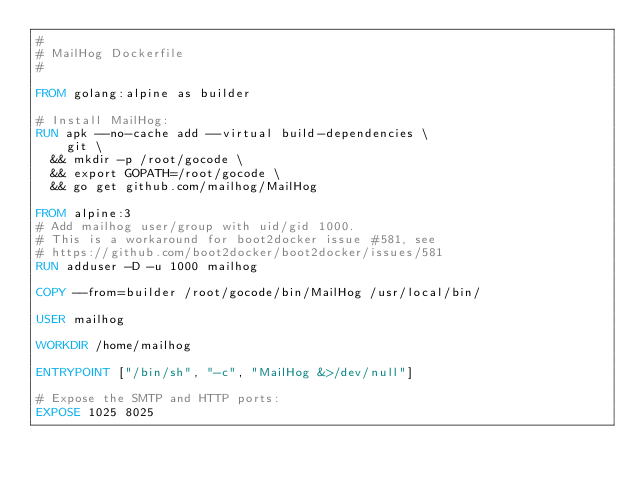<code> <loc_0><loc_0><loc_500><loc_500><_Dockerfile_>#
# MailHog Dockerfile
#

FROM golang:alpine as builder

# Install MailHog:
RUN apk --no-cache add --virtual build-dependencies \
    git \
  && mkdir -p /root/gocode \
  && export GOPATH=/root/gocode \
  && go get github.com/mailhog/MailHog

FROM alpine:3
# Add mailhog user/group with uid/gid 1000.
# This is a workaround for boot2docker issue #581, see
# https://github.com/boot2docker/boot2docker/issues/581
RUN adduser -D -u 1000 mailhog

COPY --from=builder /root/gocode/bin/MailHog /usr/local/bin/

USER mailhog

WORKDIR /home/mailhog

ENTRYPOINT ["/bin/sh", "-c", "MailHog &>/dev/null"]

# Expose the SMTP and HTTP ports:
EXPOSE 1025 8025
</code> 